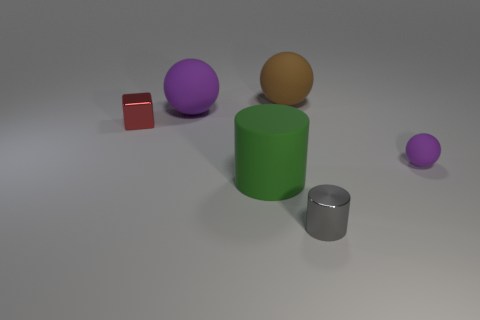There is a large ball right of the green rubber thing; what number of small shiny cylinders are right of it?
Ensure brevity in your answer.  1. Do the large sphere that is left of the big green matte thing and the small matte object have the same color?
Offer a terse response. Yes. There is a metallic object behind the purple matte sphere that is on the right side of the big purple thing; is there a gray thing on the left side of it?
Give a very brief answer. No. The small thing that is on the right side of the large cylinder and behind the large matte cylinder has what shape?
Keep it short and to the point. Sphere. Are there any other small spheres of the same color as the tiny sphere?
Your answer should be very brief. No. The metal thing on the left side of the rubber sphere that is on the left side of the big matte cylinder is what color?
Give a very brief answer. Red. How big is the purple ball behind the small metallic object to the left of the purple rubber object behind the tiny cube?
Keep it short and to the point. Large. Are the large purple sphere and the ball that is in front of the tiny red thing made of the same material?
Give a very brief answer. Yes. What size is the other purple sphere that is the same material as the large purple ball?
Ensure brevity in your answer.  Small. Are there any large brown matte things of the same shape as the tiny purple rubber object?
Your response must be concise. Yes. 